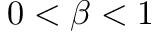<formula> <loc_0><loc_0><loc_500><loc_500>0 < \beta < 1</formula> 